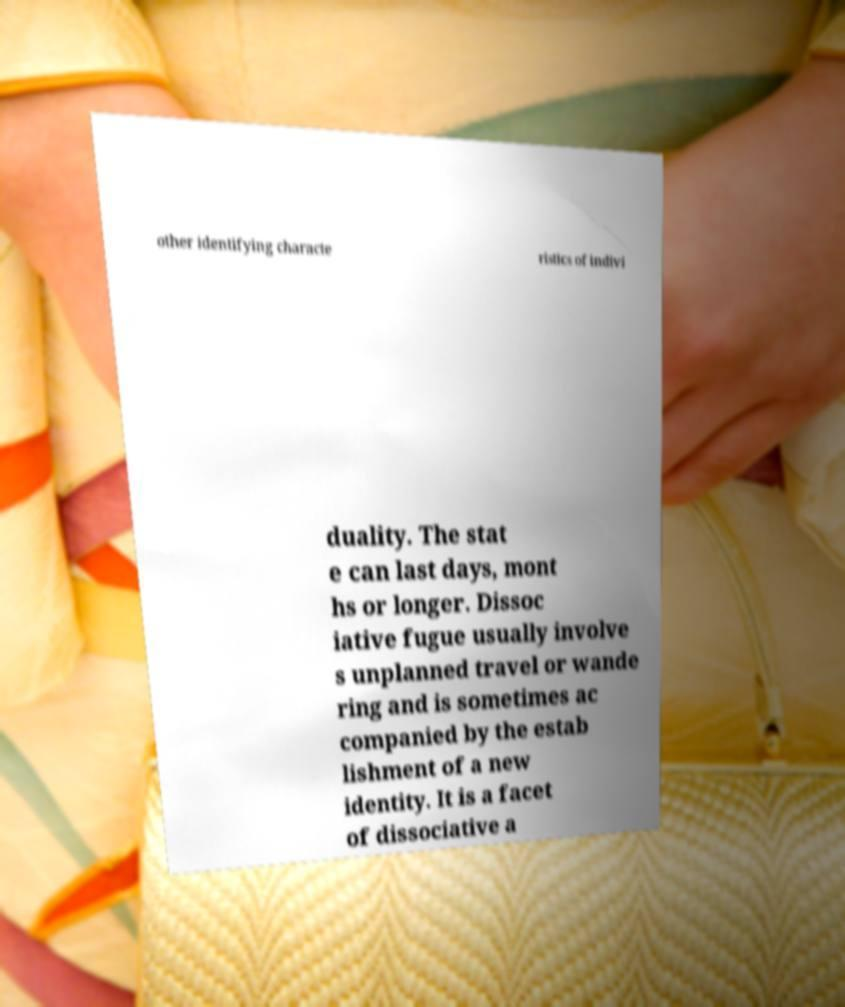Could you assist in decoding the text presented in this image and type it out clearly? other identifying characte ristics of indivi duality. The stat e can last days, mont hs or longer. Dissoc iative fugue usually involve s unplanned travel or wande ring and is sometimes ac companied by the estab lishment of a new identity. It is a facet of dissociative a 